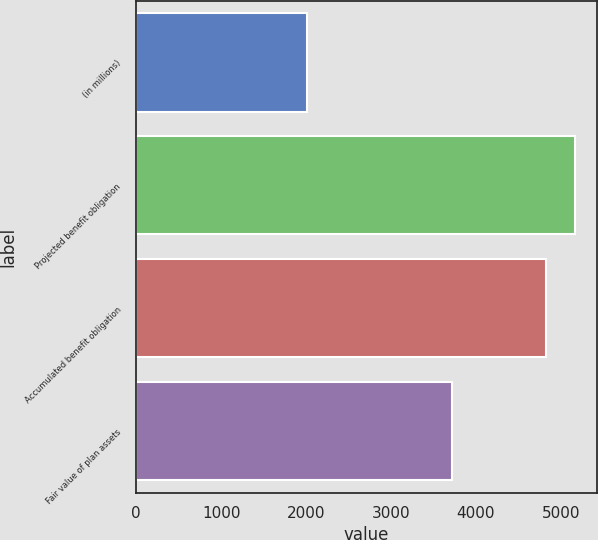Convert chart to OTSL. <chart><loc_0><loc_0><loc_500><loc_500><bar_chart><fcel>(in millions)<fcel>Projected benefit obligation<fcel>Accumulated benefit obligation<fcel>Fair value of plan assets<nl><fcel>2012<fcel>5161<fcel>4827<fcel>3720<nl></chart> 